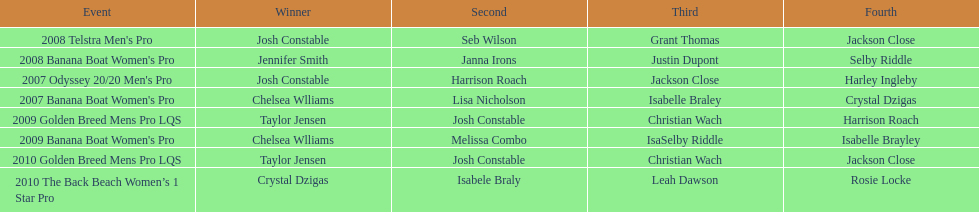In what two races did chelsea williams earn the same rank? 2007 Banana Boat Women's Pro, 2009 Banana Boat Women's Pro. 